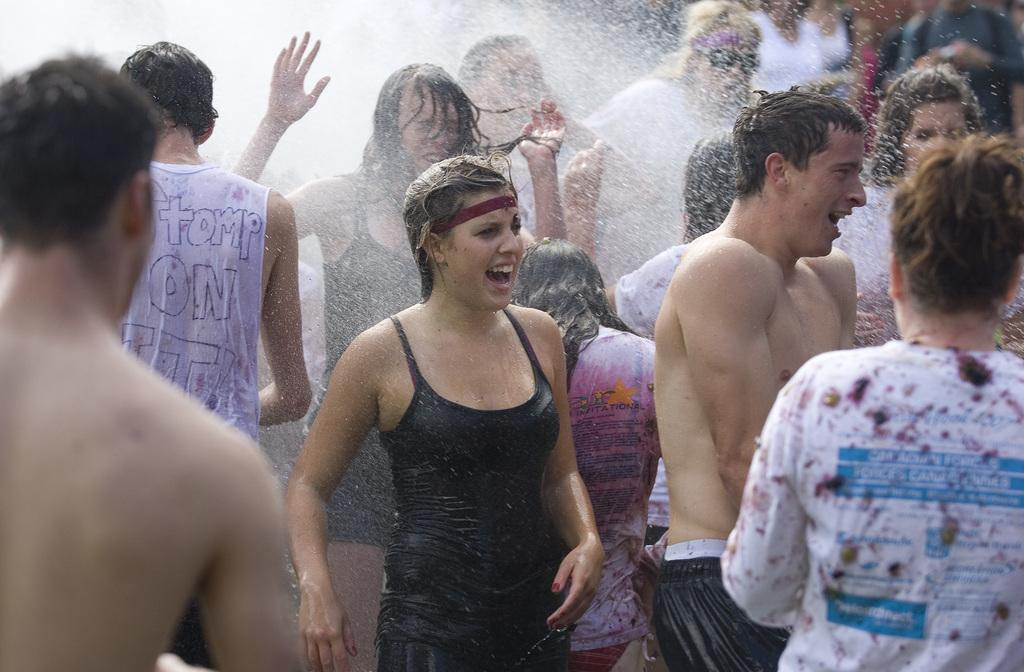How many people are in the group visible in the image? The image shows a group of people, but the exact number cannot be determined without more specific information. What is happening to the group of people in the image? Water is sprinkling on the group of people in the image. What type of voice can be heard coming from the island in the image? There is no island present in the image, so it's not possible to determine what, if any, voice might be heard coming from an island. 